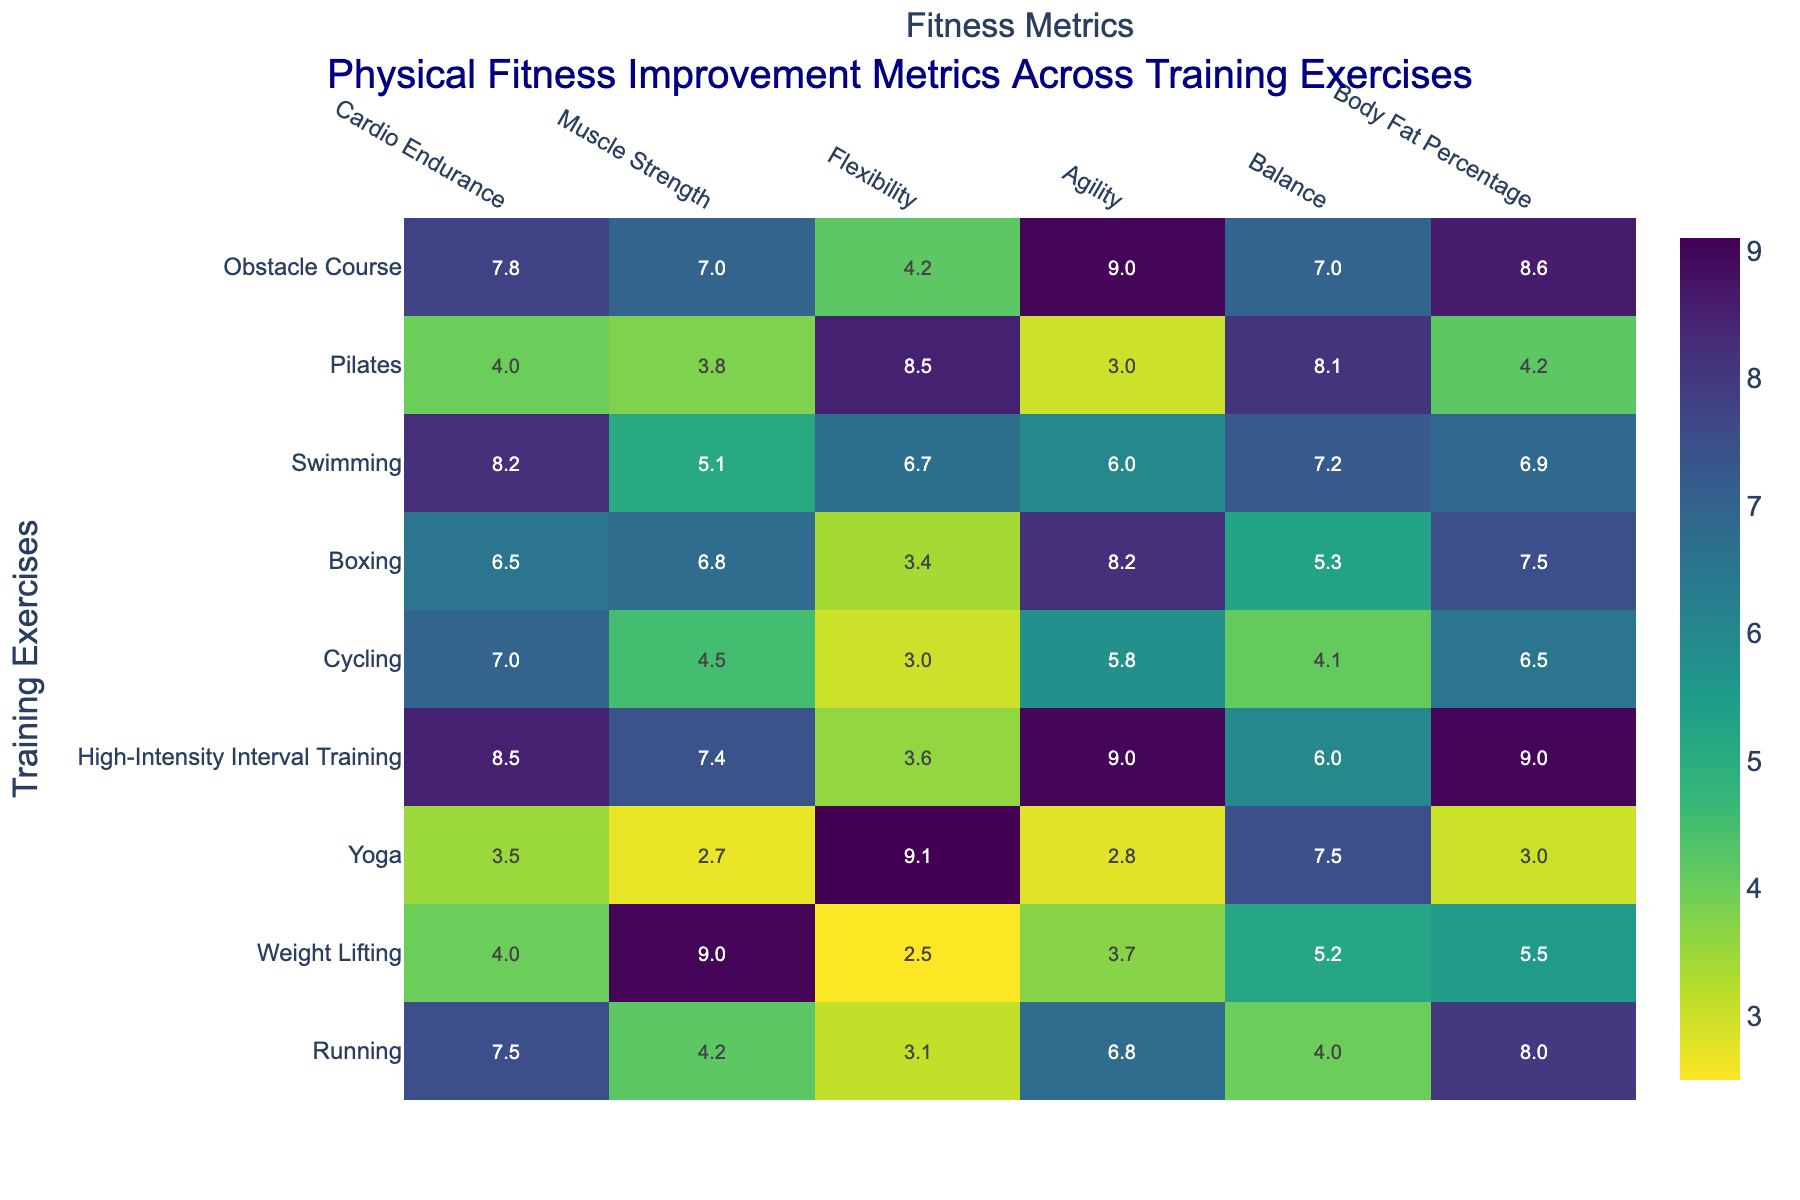What is the title of the heatmap? The title is usually displayed at the top of the heatmap. In this case, the title is "Physical Fitness Improvement Metrics Across Training Exercises".
Answer: Physical Fitness Improvement Metrics Across Training Exercises How many training exercises are listed on the heatmap? The number of training exercises can be counted from the y-axis of the heatmap. Each row corresponds to a training exercise. By counting them, we see there are 9 training exercises.
Answer: 9 Which training exercise has the highest improvement in "Body Fat Percentage"? To find this, look for the highest value in the "Body Fat Percentage" column. The highest value is 9.0, which corresponds to "High-Intensity Interval Training".
Answer: High-Intensity Interval Training Which fitness metric does Yoga improve the most? Check the row for Yoga in the heatmap and find the highest value. The highest value in the row for Yoga is 9.1 in the "Flexibility" column.
Answer: Flexibility What is the lowest improvement value for Running and in which metric is it? Locate the row for Running and find the smallest value. The lowest value in the row is 3.1, which is in the "Flexibility" metric.
Answer: Flexibility Which training exercise shows the best results in "Agility"? Find the highest value within the "Agility" column. The highest value is 9.0, and it corresponds to both "High-Intensity Interval Training" and "Obstacle Course".
Answer: High-Intensity Interval Training and Obstacle Course On average, how much does Swimming improve "Muscle Strength" and "Balance"? First, find the values for "Muscle Strength" and "Balance" in the Swimming row, which are 5.1 and 7.2 respectively. Then, calculate the average (5.1 + 7.2) / 2 = 6.15.
Answer: 6.15 Which training exercise has the most balanced improvement across all metrics? The balance can be assessed by looking for the row where the values are closest to each other. "Swimming" shows a fairly even distribution of improvements across different metrics, ranging between 5.1 and 8.2.
Answer: Swimming How much more does Boxing improve "Cardio Endurance" compared to "Flexibility"? Locate the values for "Cardio Endurance" and "Flexibility" in the Boxing row, which are 6.5 and 3.4 respectively. Then, subtract the smaller from the larger value (6.5 - 3.4) = 3.1.
Answer: 3.1 Which training exercise shows the highest improvement in "Flexibility"? Check the "Flexibility" column for the highest value. The highest value is 9.1, which corresponds to "Yoga".
Answer: Yoga 